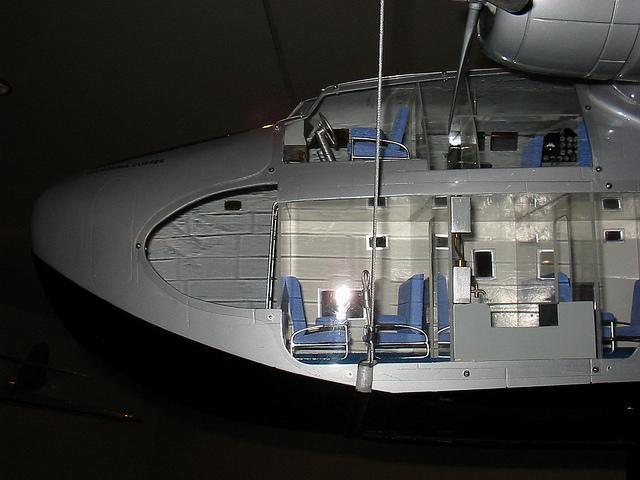How many boats are there?
Give a very brief answer. 1. How many chairs are there?
Give a very brief answer. 2. 